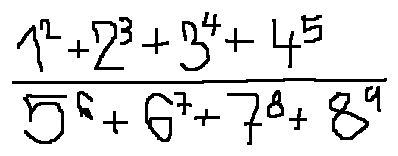<formula> <loc_0><loc_0><loc_500><loc_500>\frac { 1 ^ { 2 } + 2 ^ { 3 } + 3 ^ { 4 } + 4 ^ { 5 } } { 5 ^ { 6 } + 6 ^ { 7 } + 7 ^ { 8 } + 8 ^ { 9 } }</formula> 